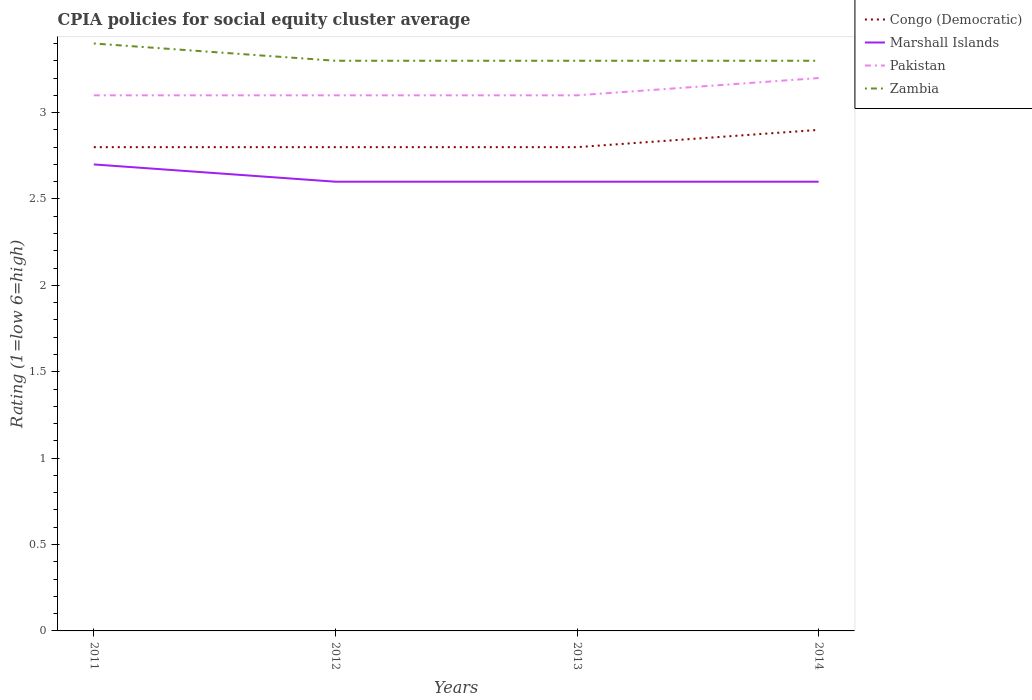Does the line corresponding to Zambia intersect with the line corresponding to Pakistan?
Your answer should be very brief. No. Is the number of lines equal to the number of legend labels?
Provide a succinct answer. Yes. What is the difference between the highest and the second highest CPIA rating in Marshall Islands?
Provide a short and direct response. 0.1. What is the difference between the highest and the lowest CPIA rating in Pakistan?
Your response must be concise. 1. Does the graph contain any zero values?
Keep it short and to the point. No. Does the graph contain grids?
Give a very brief answer. No. How many legend labels are there?
Your answer should be very brief. 4. What is the title of the graph?
Make the answer very short. CPIA policies for social equity cluster average. Does "Tajikistan" appear as one of the legend labels in the graph?
Make the answer very short. No. What is the label or title of the X-axis?
Provide a short and direct response. Years. What is the Rating (1=low 6=high) in Congo (Democratic) in 2011?
Ensure brevity in your answer.  2.8. What is the Rating (1=low 6=high) of Marshall Islands in 2011?
Your response must be concise. 2.7. What is the Rating (1=low 6=high) of Pakistan in 2011?
Ensure brevity in your answer.  3.1. What is the Rating (1=low 6=high) in Zambia in 2011?
Your answer should be very brief. 3.4. What is the Rating (1=low 6=high) of Congo (Democratic) in 2012?
Offer a very short reply. 2.8. What is the Rating (1=low 6=high) in Marshall Islands in 2012?
Your answer should be compact. 2.6. What is the Rating (1=low 6=high) in Pakistan in 2012?
Make the answer very short. 3.1. What is the Rating (1=low 6=high) of Marshall Islands in 2013?
Provide a succinct answer. 2.6. Across all years, what is the maximum Rating (1=low 6=high) of Congo (Democratic)?
Give a very brief answer. 2.9. Across all years, what is the maximum Rating (1=low 6=high) in Marshall Islands?
Your answer should be compact. 2.7. Across all years, what is the maximum Rating (1=low 6=high) of Pakistan?
Your answer should be very brief. 3.2. Across all years, what is the minimum Rating (1=low 6=high) in Marshall Islands?
Provide a succinct answer. 2.6. Across all years, what is the minimum Rating (1=low 6=high) in Pakistan?
Ensure brevity in your answer.  3.1. What is the total Rating (1=low 6=high) in Congo (Democratic) in the graph?
Offer a terse response. 11.3. What is the difference between the Rating (1=low 6=high) in Pakistan in 2011 and that in 2012?
Provide a succinct answer. 0. What is the difference between the Rating (1=low 6=high) of Zambia in 2011 and that in 2012?
Make the answer very short. 0.1. What is the difference between the Rating (1=low 6=high) in Congo (Democratic) in 2011 and that in 2013?
Your answer should be compact. 0. What is the difference between the Rating (1=low 6=high) of Marshall Islands in 2011 and that in 2013?
Ensure brevity in your answer.  0.1. What is the difference between the Rating (1=low 6=high) in Congo (Democratic) in 2011 and that in 2014?
Give a very brief answer. -0.1. What is the difference between the Rating (1=low 6=high) of Pakistan in 2011 and that in 2014?
Ensure brevity in your answer.  -0.1. What is the difference between the Rating (1=low 6=high) in Congo (Democratic) in 2012 and that in 2013?
Offer a very short reply. 0. What is the difference between the Rating (1=low 6=high) of Congo (Democratic) in 2012 and that in 2014?
Provide a succinct answer. -0.1. What is the difference between the Rating (1=low 6=high) of Marshall Islands in 2012 and that in 2014?
Make the answer very short. 0. What is the difference between the Rating (1=low 6=high) of Zambia in 2012 and that in 2014?
Your response must be concise. 0. What is the difference between the Rating (1=low 6=high) in Congo (Democratic) in 2013 and that in 2014?
Give a very brief answer. -0.1. What is the difference between the Rating (1=low 6=high) in Marshall Islands in 2013 and that in 2014?
Provide a short and direct response. 0. What is the difference between the Rating (1=low 6=high) of Zambia in 2013 and that in 2014?
Offer a terse response. 0. What is the difference between the Rating (1=low 6=high) in Congo (Democratic) in 2011 and the Rating (1=low 6=high) in Marshall Islands in 2012?
Ensure brevity in your answer.  0.2. What is the difference between the Rating (1=low 6=high) of Congo (Democratic) in 2011 and the Rating (1=low 6=high) of Marshall Islands in 2013?
Your answer should be compact. 0.2. What is the difference between the Rating (1=low 6=high) of Congo (Democratic) in 2011 and the Rating (1=low 6=high) of Zambia in 2013?
Provide a short and direct response. -0.5. What is the difference between the Rating (1=low 6=high) in Pakistan in 2011 and the Rating (1=low 6=high) in Zambia in 2013?
Provide a succinct answer. -0.2. What is the difference between the Rating (1=low 6=high) in Congo (Democratic) in 2011 and the Rating (1=low 6=high) in Pakistan in 2014?
Provide a succinct answer. -0.4. What is the difference between the Rating (1=low 6=high) of Congo (Democratic) in 2011 and the Rating (1=low 6=high) of Zambia in 2014?
Provide a short and direct response. -0.5. What is the difference between the Rating (1=low 6=high) in Marshall Islands in 2011 and the Rating (1=low 6=high) in Pakistan in 2014?
Give a very brief answer. -0.5. What is the difference between the Rating (1=low 6=high) of Pakistan in 2011 and the Rating (1=low 6=high) of Zambia in 2014?
Give a very brief answer. -0.2. What is the difference between the Rating (1=low 6=high) in Congo (Democratic) in 2012 and the Rating (1=low 6=high) in Marshall Islands in 2013?
Your answer should be compact. 0.2. What is the difference between the Rating (1=low 6=high) of Congo (Democratic) in 2012 and the Rating (1=low 6=high) of Pakistan in 2013?
Offer a very short reply. -0.3. What is the difference between the Rating (1=low 6=high) of Congo (Democratic) in 2012 and the Rating (1=low 6=high) of Zambia in 2013?
Offer a very short reply. -0.5. What is the difference between the Rating (1=low 6=high) of Pakistan in 2012 and the Rating (1=low 6=high) of Zambia in 2013?
Keep it short and to the point. -0.2. What is the difference between the Rating (1=low 6=high) in Congo (Democratic) in 2012 and the Rating (1=low 6=high) in Zambia in 2014?
Your answer should be compact. -0.5. What is the difference between the Rating (1=low 6=high) of Pakistan in 2012 and the Rating (1=low 6=high) of Zambia in 2014?
Offer a terse response. -0.2. What is the difference between the Rating (1=low 6=high) in Congo (Democratic) in 2013 and the Rating (1=low 6=high) in Pakistan in 2014?
Your answer should be very brief. -0.4. What is the difference between the Rating (1=low 6=high) in Congo (Democratic) in 2013 and the Rating (1=low 6=high) in Zambia in 2014?
Your response must be concise. -0.5. What is the difference between the Rating (1=low 6=high) of Marshall Islands in 2013 and the Rating (1=low 6=high) of Pakistan in 2014?
Your response must be concise. -0.6. What is the difference between the Rating (1=low 6=high) of Marshall Islands in 2013 and the Rating (1=low 6=high) of Zambia in 2014?
Your answer should be compact. -0.7. What is the average Rating (1=low 6=high) of Congo (Democratic) per year?
Ensure brevity in your answer.  2.83. What is the average Rating (1=low 6=high) of Marshall Islands per year?
Provide a succinct answer. 2.62. What is the average Rating (1=low 6=high) in Pakistan per year?
Make the answer very short. 3.12. What is the average Rating (1=low 6=high) in Zambia per year?
Ensure brevity in your answer.  3.33. In the year 2011, what is the difference between the Rating (1=low 6=high) in Congo (Democratic) and Rating (1=low 6=high) in Pakistan?
Give a very brief answer. -0.3. In the year 2011, what is the difference between the Rating (1=low 6=high) of Congo (Democratic) and Rating (1=low 6=high) of Zambia?
Your answer should be compact. -0.6. In the year 2012, what is the difference between the Rating (1=low 6=high) of Congo (Democratic) and Rating (1=low 6=high) of Marshall Islands?
Offer a terse response. 0.2. In the year 2012, what is the difference between the Rating (1=low 6=high) in Congo (Democratic) and Rating (1=low 6=high) in Pakistan?
Your answer should be compact. -0.3. In the year 2013, what is the difference between the Rating (1=low 6=high) of Pakistan and Rating (1=low 6=high) of Zambia?
Provide a short and direct response. -0.2. In the year 2014, what is the difference between the Rating (1=low 6=high) of Congo (Democratic) and Rating (1=low 6=high) of Zambia?
Provide a succinct answer. -0.4. In the year 2014, what is the difference between the Rating (1=low 6=high) of Pakistan and Rating (1=low 6=high) of Zambia?
Ensure brevity in your answer.  -0.1. What is the ratio of the Rating (1=low 6=high) in Congo (Democratic) in 2011 to that in 2012?
Provide a succinct answer. 1. What is the ratio of the Rating (1=low 6=high) of Pakistan in 2011 to that in 2012?
Give a very brief answer. 1. What is the ratio of the Rating (1=low 6=high) in Zambia in 2011 to that in 2012?
Make the answer very short. 1.03. What is the ratio of the Rating (1=low 6=high) in Congo (Democratic) in 2011 to that in 2013?
Offer a very short reply. 1. What is the ratio of the Rating (1=low 6=high) in Zambia in 2011 to that in 2013?
Ensure brevity in your answer.  1.03. What is the ratio of the Rating (1=low 6=high) in Congo (Democratic) in 2011 to that in 2014?
Keep it short and to the point. 0.97. What is the ratio of the Rating (1=low 6=high) of Pakistan in 2011 to that in 2014?
Ensure brevity in your answer.  0.97. What is the ratio of the Rating (1=low 6=high) in Zambia in 2011 to that in 2014?
Offer a terse response. 1.03. What is the ratio of the Rating (1=low 6=high) of Congo (Democratic) in 2012 to that in 2013?
Offer a very short reply. 1. What is the ratio of the Rating (1=low 6=high) in Marshall Islands in 2012 to that in 2013?
Provide a short and direct response. 1. What is the ratio of the Rating (1=low 6=high) in Pakistan in 2012 to that in 2013?
Your answer should be very brief. 1. What is the ratio of the Rating (1=low 6=high) of Zambia in 2012 to that in 2013?
Keep it short and to the point. 1. What is the ratio of the Rating (1=low 6=high) in Congo (Democratic) in 2012 to that in 2014?
Provide a short and direct response. 0.97. What is the ratio of the Rating (1=low 6=high) in Marshall Islands in 2012 to that in 2014?
Your answer should be very brief. 1. What is the ratio of the Rating (1=low 6=high) of Pakistan in 2012 to that in 2014?
Provide a succinct answer. 0.97. What is the ratio of the Rating (1=low 6=high) in Congo (Democratic) in 2013 to that in 2014?
Offer a very short reply. 0.97. What is the ratio of the Rating (1=low 6=high) of Pakistan in 2013 to that in 2014?
Make the answer very short. 0.97. What is the difference between the highest and the second highest Rating (1=low 6=high) in Marshall Islands?
Offer a very short reply. 0.1. What is the difference between the highest and the second highest Rating (1=low 6=high) of Pakistan?
Make the answer very short. 0.1. What is the difference between the highest and the second highest Rating (1=low 6=high) of Zambia?
Your response must be concise. 0.1. What is the difference between the highest and the lowest Rating (1=low 6=high) in Marshall Islands?
Keep it short and to the point. 0.1. What is the difference between the highest and the lowest Rating (1=low 6=high) of Pakistan?
Your answer should be very brief. 0.1. 